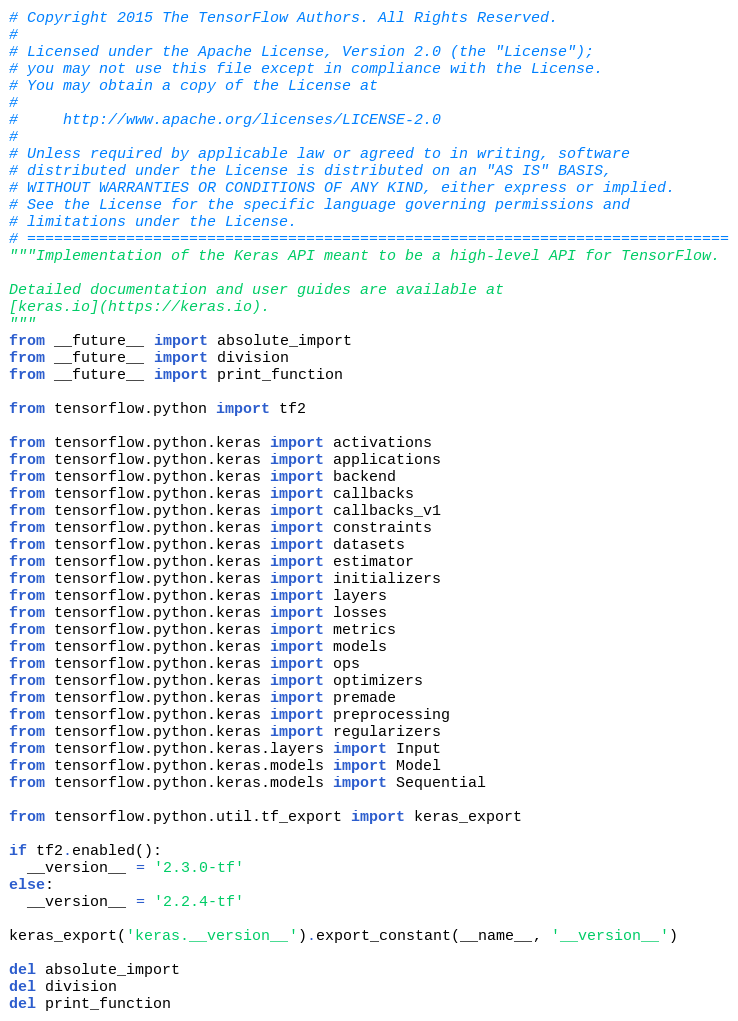Convert code to text. <code><loc_0><loc_0><loc_500><loc_500><_Python_># Copyright 2015 The TensorFlow Authors. All Rights Reserved.
#
# Licensed under the Apache License, Version 2.0 (the "License");
# you may not use this file except in compliance with the License.
# You may obtain a copy of the License at
#
#     http://www.apache.org/licenses/LICENSE-2.0
#
# Unless required by applicable law or agreed to in writing, software
# distributed under the License is distributed on an "AS IS" BASIS,
# WITHOUT WARRANTIES OR CONDITIONS OF ANY KIND, either express or implied.
# See the License for the specific language governing permissions and
# limitations under the License.
# ==============================================================================
"""Implementation of the Keras API meant to be a high-level API for TensorFlow.

Detailed documentation and user guides are available at
[keras.io](https://keras.io).
"""
from __future__ import absolute_import
from __future__ import division
from __future__ import print_function

from tensorflow.python import tf2

from tensorflow.python.keras import activations
from tensorflow.python.keras import applications
from tensorflow.python.keras import backend
from tensorflow.python.keras import callbacks
from tensorflow.python.keras import callbacks_v1
from tensorflow.python.keras import constraints
from tensorflow.python.keras import datasets
from tensorflow.python.keras import estimator
from tensorflow.python.keras import initializers
from tensorflow.python.keras import layers
from tensorflow.python.keras import losses
from tensorflow.python.keras import metrics
from tensorflow.python.keras import models
from tensorflow.python.keras import ops
from tensorflow.python.keras import optimizers
from tensorflow.python.keras import premade
from tensorflow.python.keras import preprocessing
from tensorflow.python.keras import regularizers
from tensorflow.python.keras.layers import Input
from tensorflow.python.keras.models import Model
from tensorflow.python.keras.models import Sequential

from tensorflow.python.util.tf_export import keras_export

if tf2.enabled():
  __version__ = '2.3.0-tf'
else:
  __version__ = '2.2.4-tf'

keras_export('keras.__version__').export_constant(__name__, '__version__')

del absolute_import
del division
del print_function
</code> 